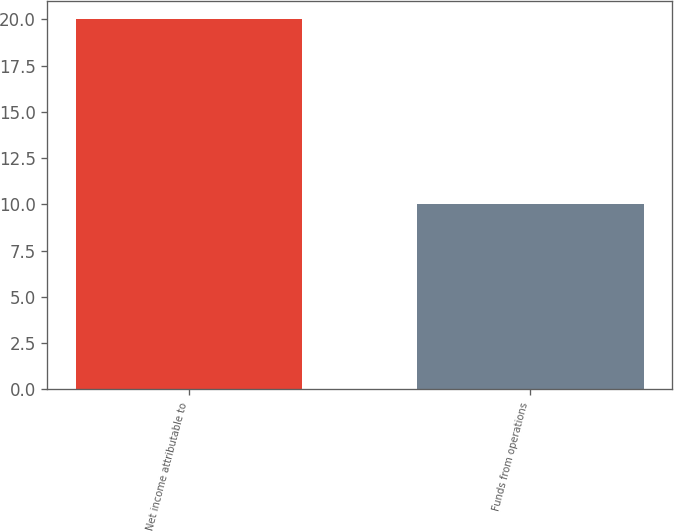Convert chart. <chart><loc_0><loc_0><loc_500><loc_500><bar_chart><fcel>Net income attributable to<fcel>Funds from operations<nl><fcel>20<fcel>10<nl></chart> 